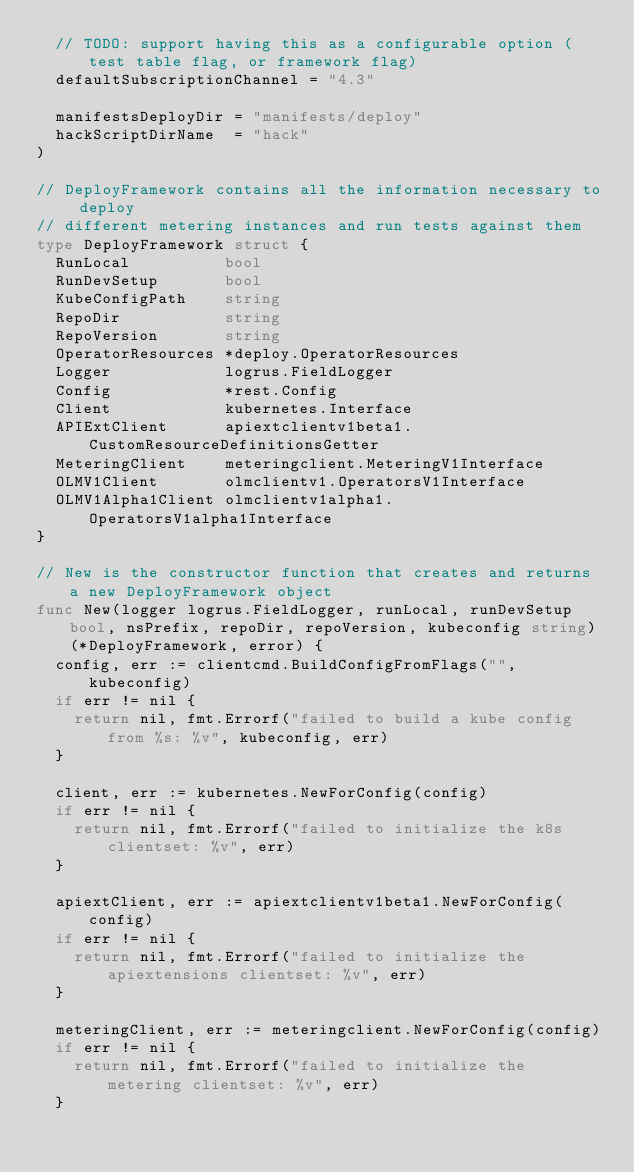<code> <loc_0><loc_0><loc_500><loc_500><_Go_>	// TODO: support having this as a configurable option (test table flag, or framework flag)
	defaultSubscriptionChannel = "4.3"

	manifestsDeployDir = "manifests/deploy"
	hackScriptDirName  = "hack"
)

// DeployFramework contains all the information necessary to deploy
// different metering instances and run tests against them
type DeployFramework struct {
	RunLocal          bool
	RunDevSetup       bool
	KubeConfigPath    string
	RepoDir           string
	RepoVersion       string
	OperatorResources *deploy.OperatorResources
	Logger            logrus.FieldLogger
	Config            *rest.Config
	Client            kubernetes.Interface
	APIExtClient      apiextclientv1beta1.CustomResourceDefinitionsGetter
	MeteringClient    meteringclient.MeteringV1Interface
	OLMV1Client       olmclientv1.OperatorsV1Interface
	OLMV1Alpha1Client olmclientv1alpha1.OperatorsV1alpha1Interface
}

// New is the constructor function that creates and returns a new DeployFramework object
func New(logger logrus.FieldLogger, runLocal, runDevSetup bool, nsPrefix, repoDir, repoVersion, kubeconfig string) (*DeployFramework, error) {
	config, err := clientcmd.BuildConfigFromFlags("", kubeconfig)
	if err != nil {
		return nil, fmt.Errorf("failed to build a kube config from %s: %v", kubeconfig, err)
	}

	client, err := kubernetes.NewForConfig(config)
	if err != nil {
		return nil, fmt.Errorf("failed to initialize the k8s clientset: %v", err)
	}

	apiextClient, err := apiextclientv1beta1.NewForConfig(config)
	if err != nil {
		return nil, fmt.Errorf("failed to initialize the apiextensions clientset: %v", err)
	}

	meteringClient, err := meteringclient.NewForConfig(config)
	if err != nil {
		return nil, fmt.Errorf("failed to initialize the metering clientset: %v", err)
	}
</code> 